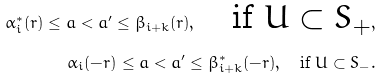Convert formula to latex. <formula><loc_0><loc_0><loc_500><loc_500>\alpha ^ { * } _ { i } ( r ) \leq a < a ^ { \prime } \leq \beta _ { i + k } ( r ) , \quad \text {if $U \subset S_{+}$} , \\ \alpha _ { i } ( - r ) \leq a < a ^ { \prime } \leq \beta _ { i + k } ^ { * } ( - r ) , \quad \text {if $U \subset S_{-}$} .</formula> 